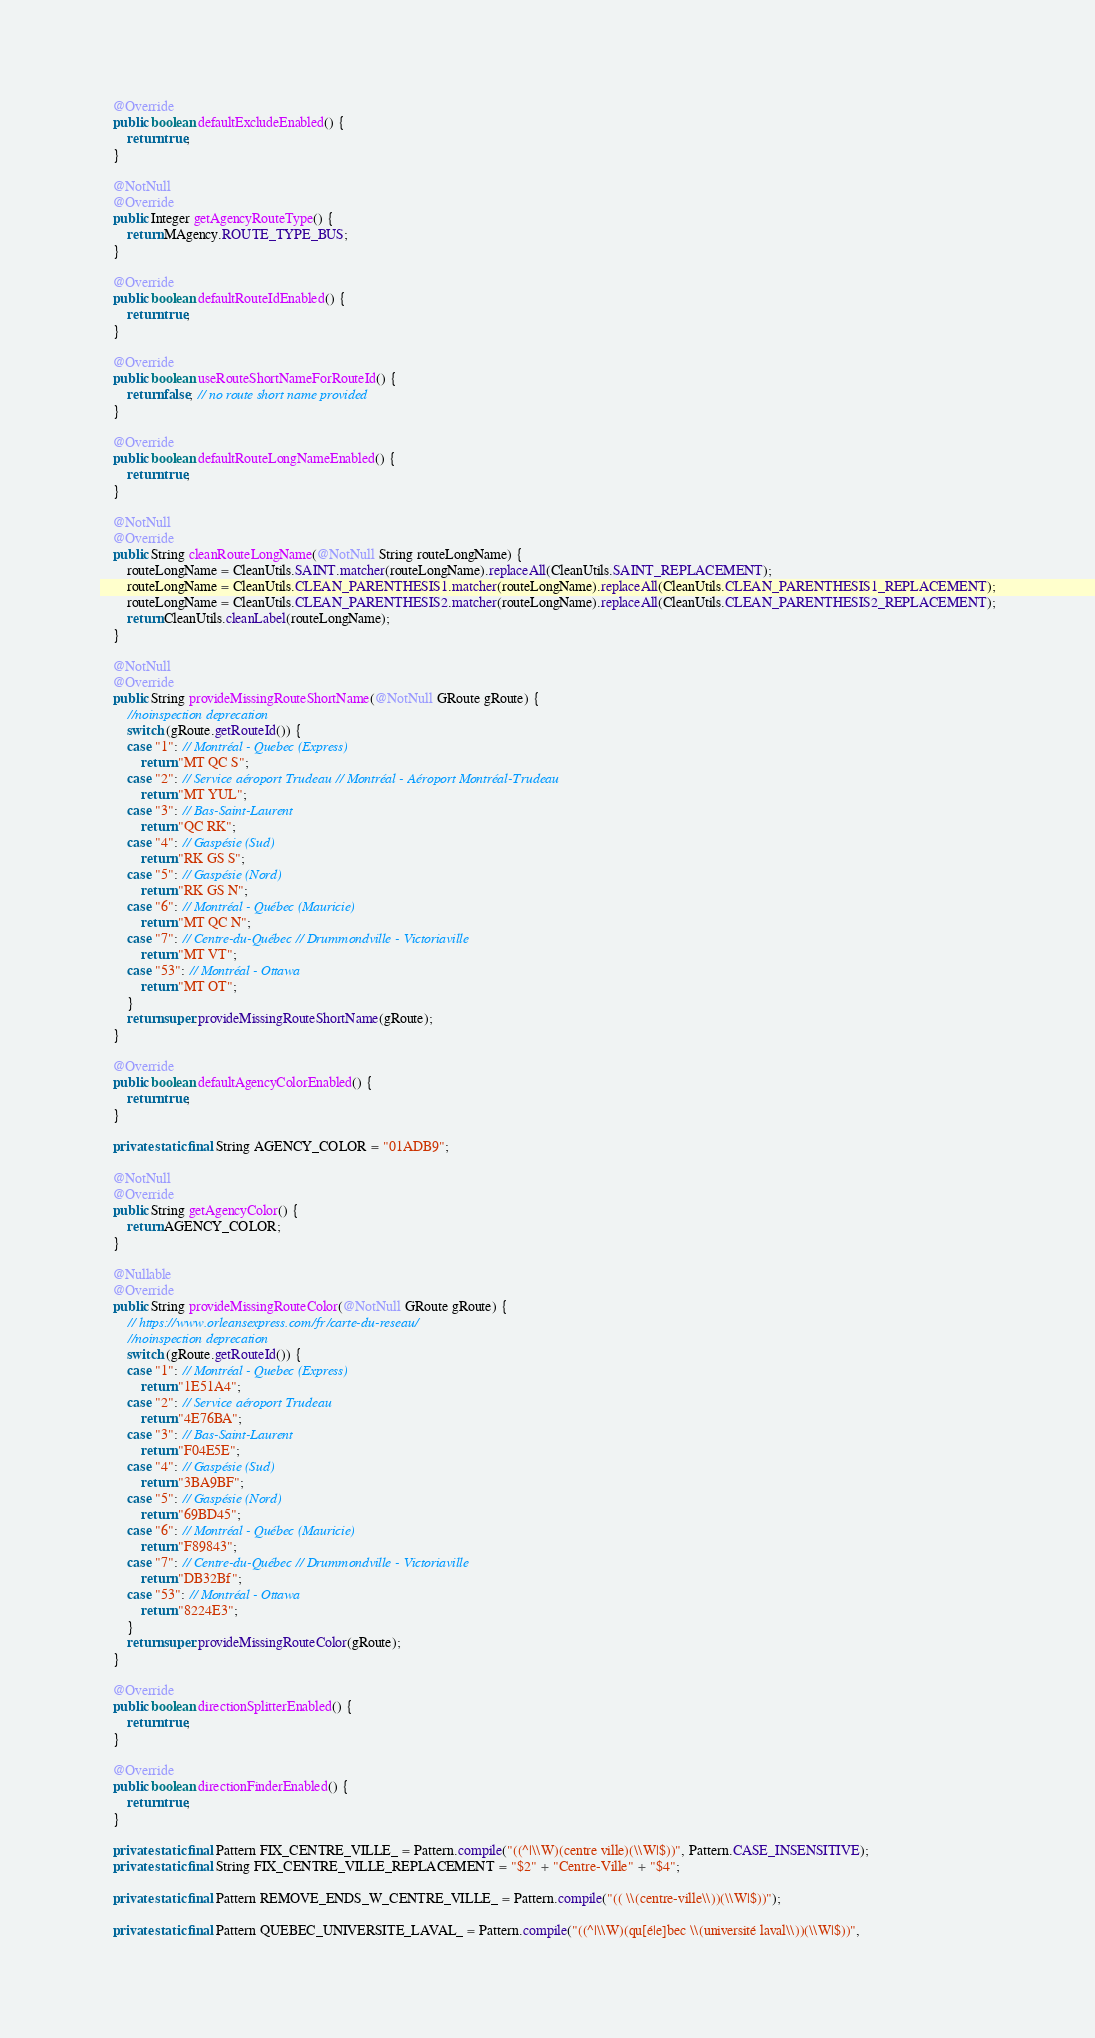<code> <loc_0><loc_0><loc_500><loc_500><_Java_>
	@Override
	public boolean defaultExcludeEnabled() {
		return true;
	}

	@NotNull
	@Override
	public Integer getAgencyRouteType() {
		return MAgency.ROUTE_TYPE_BUS;
	}

	@Override
	public boolean defaultRouteIdEnabled() {
		return true;
	}

	@Override
	public boolean useRouteShortNameForRouteId() {
		return false; // no route short name provided
	}

	@Override
	public boolean defaultRouteLongNameEnabled() {
		return true;
	}

	@NotNull
	@Override
	public String cleanRouteLongName(@NotNull String routeLongName) {
		routeLongName = CleanUtils.SAINT.matcher(routeLongName).replaceAll(CleanUtils.SAINT_REPLACEMENT);
		routeLongName = CleanUtils.CLEAN_PARENTHESIS1.matcher(routeLongName).replaceAll(CleanUtils.CLEAN_PARENTHESIS1_REPLACEMENT);
		routeLongName = CleanUtils.CLEAN_PARENTHESIS2.matcher(routeLongName).replaceAll(CleanUtils.CLEAN_PARENTHESIS2_REPLACEMENT);
		return CleanUtils.cleanLabel(routeLongName);
	}

	@NotNull
	@Override
	public String provideMissingRouteShortName(@NotNull GRoute gRoute) {
		//noinspection deprecation
		switch (gRoute.getRouteId()) {
		case "1": // Montréal - Quebec (Express)
			return "MT QC S";
		case "2": // Service aéroport Trudeau // Montréal - Aéroport Montréal-Trudeau
			return "MT YUL";
		case "3": // Bas-Saint-Laurent
			return "QC RK";
		case "4": // Gaspésie (Sud)
			return "RK GS S";
		case "5": // Gaspésie (Nord)
			return "RK GS N";
		case "6": // Montréal - Québec (Mauricie)
			return "MT QC N";
		case "7": // Centre-du-Québec // Drummondville - Victoriaville
			return "MT VT";
		case "53": // Montréal - Ottawa
			return "MT OT";
		}
		return super.provideMissingRouteShortName(gRoute);
	}

	@Override
	public boolean defaultAgencyColorEnabled() {
		return true;
	}

	private static final String AGENCY_COLOR = "01ADB9";

	@NotNull
	@Override
	public String getAgencyColor() {
		return AGENCY_COLOR;
	}

	@Nullable
	@Override
	public String provideMissingRouteColor(@NotNull GRoute gRoute) {
		// https://www.orleansexpress.com/fr/carte-du-reseau/
		//noinspection deprecation
		switch (gRoute.getRouteId()) {
		case "1": // Montréal - Quebec (Express)
			return "1E51A4";
		case "2": // Service aéroport Trudeau
			return "4E76BA";
		case "3": // Bas-Saint-Laurent
			return "F04E5E";
		case "4": // Gaspésie (Sud)
			return "3BA9BF";
		case "5": // Gaspésie (Nord)
			return "69BD45";
		case "6": // Montréal - Québec (Mauricie)
			return "F89843";
		case "7": // Centre-du-Québec // Drummondville - Victoriaville
			return "DB32Bf";
		case "53": // Montréal - Ottawa
			return "8224E3";
		}
		return super.provideMissingRouteColor(gRoute);
	}

	@Override
	public boolean directionSplitterEnabled() {
		return true;
	}

	@Override
	public boolean directionFinderEnabled() {
		return true;
	}

	private static final Pattern FIX_CENTRE_VILLE_ = Pattern.compile("((^|\\W)(centre ville)(\\W|$))", Pattern.CASE_INSENSITIVE);
	private static final String FIX_CENTRE_VILLE_REPLACEMENT = "$2" + "Centre-Ville" + "$4";

	private static final Pattern REMOVE_ENDS_W_CENTRE_VILLE_ = Pattern.compile("(( \\(centre-ville\\))(\\W|$))");

	private static final Pattern QUEBEC_UNIVERSITE_LAVAL_ = Pattern.compile("((^|\\W)(qu[é|e]bec \\(université laval\\))(\\W|$))",</code> 